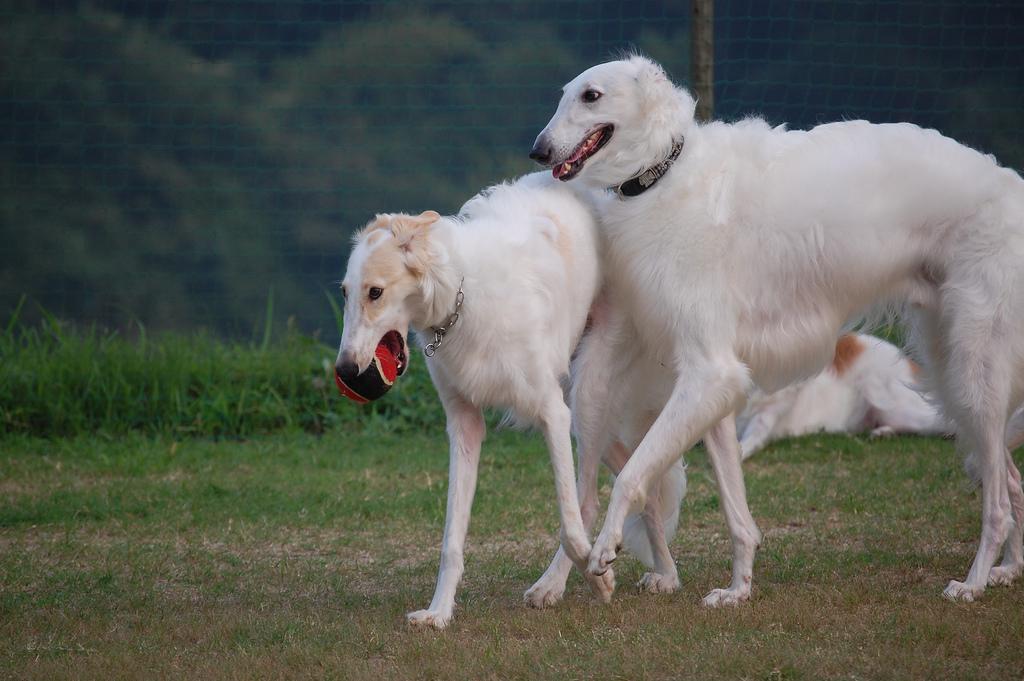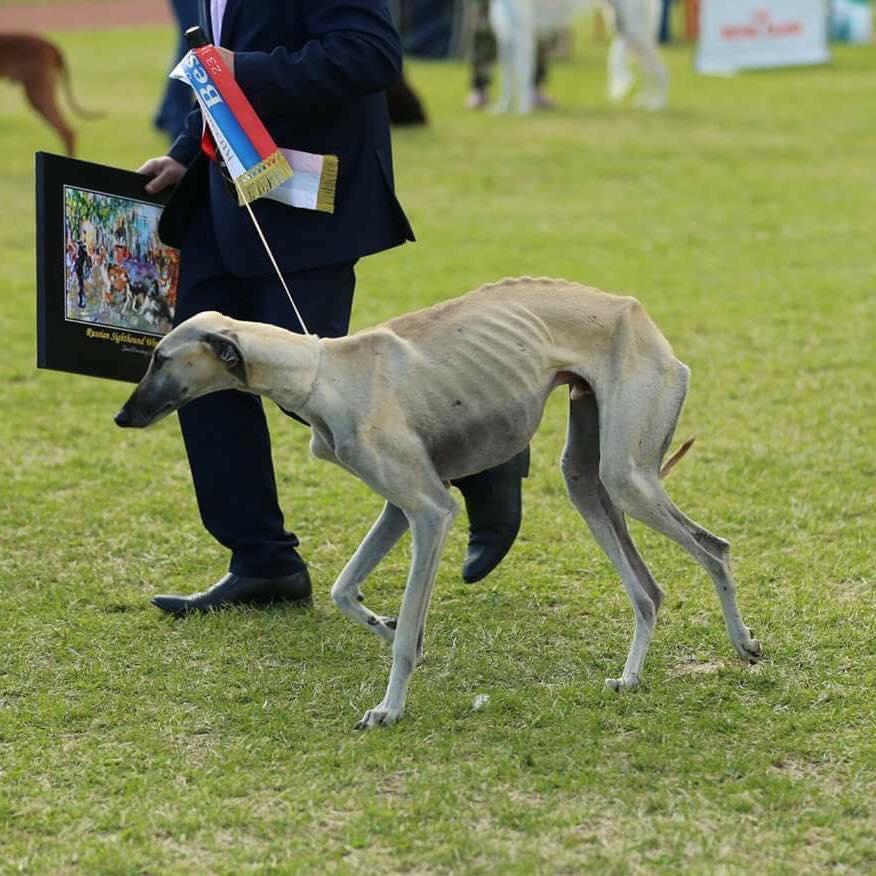The first image is the image on the left, the second image is the image on the right. For the images shown, is this caption "An image contains exactly two dogs." true? Answer yes or no. Yes. The first image is the image on the left, the second image is the image on the right. Considering the images on both sides, is "Each image contains exactly one hound, and the hound on the right is white and stands with its body turned rightward, while the dog on the left has orange-and-white fur." valid? Answer yes or no. No. 